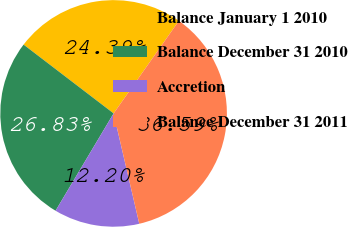Convert chart. <chart><loc_0><loc_0><loc_500><loc_500><pie_chart><fcel>Balance January 1 2010<fcel>Balance December 31 2010<fcel>Accretion<fcel>Balance December 31 2011<nl><fcel>24.39%<fcel>26.83%<fcel>12.2%<fcel>36.59%<nl></chart> 